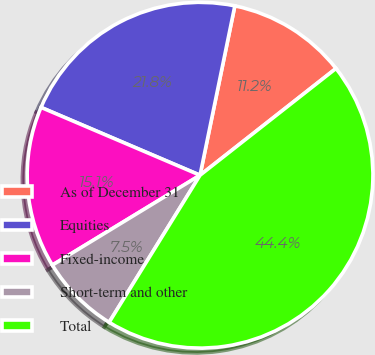Convert chart to OTSL. <chart><loc_0><loc_0><loc_500><loc_500><pie_chart><fcel>As of December 31<fcel>Equities<fcel>Fixed-income<fcel>Short-term and other<fcel>Total<nl><fcel>11.18%<fcel>21.81%<fcel>15.12%<fcel>7.49%<fcel>44.41%<nl></chart> 